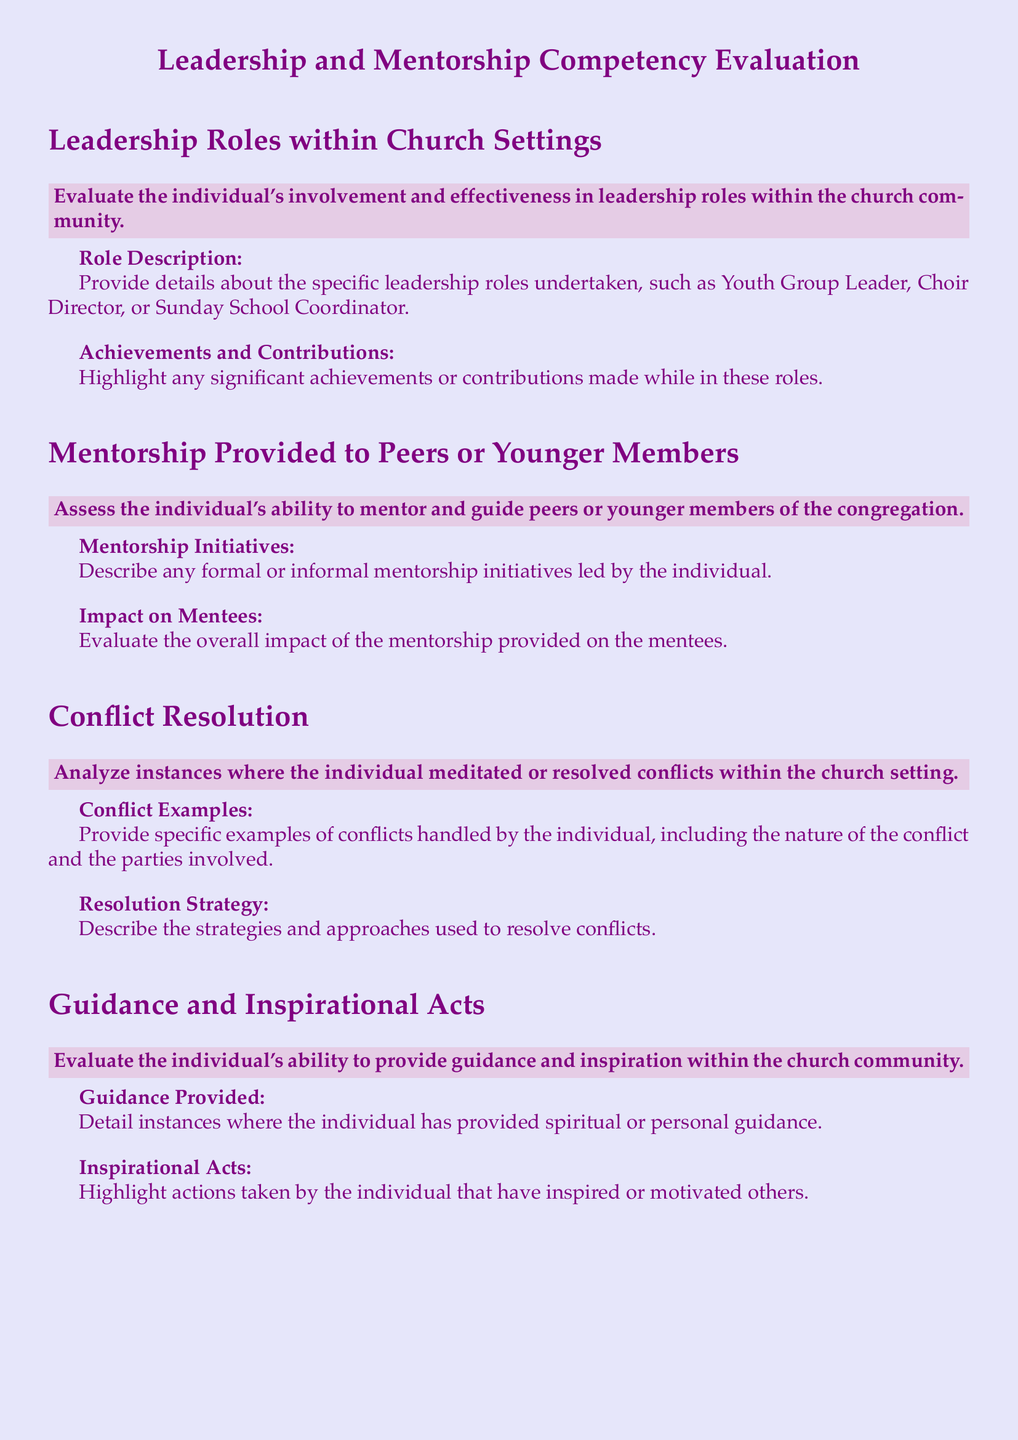What is the title of the document? The title of the document is stated prominently at the beginning.
Answer: Leadership and Mentorship Competency Evaluation What role descriptions are requested in the appraisal? The document specifically asks for details on various leadership roles undertaken.
Answer: Youth Group Leader, Choir Director, Sunday School Coordinator What are the two sections under mentorship? The document details two main areas relating to mentorship.
Answer: Mentorship Initiatives, Impact on Mentees What type of conflicts should be analyzed in the evaluation? The document specifies the need to analyze instances where conflicts occurred in the church setting.
Answer: Conflicts handled by the individual What does the guidance section require? The appraisal includes a section that specifically asks for the individual's ability to provide certain forms of support.
Answer: Spiritual or personal guidance What color is used for the background of the document? The document specifies a particular color as its background.
Answer: Light purple What is the general purpose of this appraisal form? The overall purpose of the document is clarified in its title.
Answer: Evaluate leadership and mentorship competency What format is used for presenting sections in the document? The document has a clear and organized way of showcasing its sections.
Answer: Section box format What does the inspirational acts section highlight? The document includes a specific component that asks for actions taken by the individual.
Answer: Actions that inspire or motivate others 